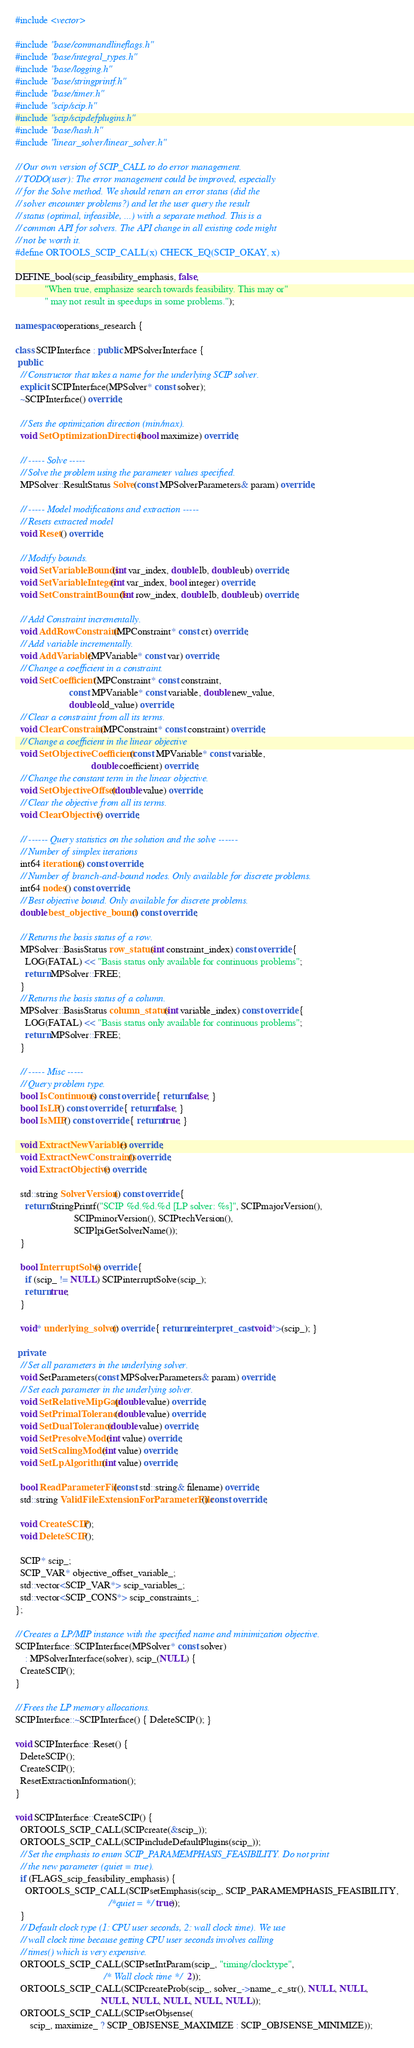Convert code to text. <code><loc_0><loc_0><loc_500><loc_500><_C++_>#include <vector>

#include "base/commandlineflags.h"
#include "base/integral_types.h"
#include "base/logging.h"
#include "base/stringprintf.h"
#include "base/timer.h"
#include "scip/scip.h"
#include "scip/scipdefplugins.h"
#include "base/hash.h"
#include "linear_solver/linear_solver.h"

// Our own version of SCIP_CALL to do error management.
// TODO(user): The error management could be improved, especially
// for the Solve method. We should return an error status (did the
// solver encounter problems?) and let the user query the result
// status (optimal, infeasible, ...) with a separate method. This is a
// common API for solvers. The API change in all existing code might
// not be worth it.
#define ORTOOLS_SCIP_CALL(x) CHECK_EQ(SCIP_OKAY, x)

DEFINE_bool(scip_feasibility_emphasis, false,
            "When true, emphasize search towards feasibility. This may or"
            " may not result in speedups in some problems.");

namespace operations_research {

class SCIPInterface : public MPSolverInterface {
 public:
  // Constructor that takes a name for the underlying SCIP solver.
  explicit SCIPInterface(MPSolver* const solver);
  ~SCIPInterface() override;

  // Sets the optimization direction (min/max).
  void SetOptimizationDirection(bool maximize) override;

  // ----- Solve -----
  // Solve the problem using the parameter values specified.
  MPSolver::ResultStatus Solve(const MPSolverParameters& param) override;

  // ----- Model modifications and extraction -----
  // Resets extracted model
  void Reset() override;

  // Modify bounds.
  void SetVariableBounds(int var_index, double lb, double ub) override;
  void SetVariableInteger(int var_index, bool integer) override;
  void SetConstraintBounds(int row_index, double lb, double ub) override;

  // Add Constraint incrementally.
  void AddRowConstraint(MPConstraint* const ct) override;
  // Add variable incrementally.
  void AddVariable(MPVariable* const var) override;
  // Change a coefficient in a constraint.
  void SetCoefficient(MPConstraint* const constraint,
                      const MPVariable* const variable, double new_value,
                      double old_value) override;
  // Clear a constraint from all its terms.
  void ClearConstraint(MPConstraint* const constraint) override;
  // Change a coefficient in the linear objective
  void SetObjectiveCoefficient(const MPVariable* const variable,
                               double coefficient) override;
  // Change the constant term in the linear objective.
  void SetObjectiveOffset(double value) override;
  // Clear the objective from all its terms.
  void ClearObjective() override;

  // ------ Query statistics on the solution and the solve ------
  // Number of simplex iterations
  int64 iterations() const override;
  // Number of branch-and-bound nodes. Only available for discrete problems.
  int64 nodes() const override;
  // Best objective bound. Only available for discrete problems.
  double best_objective_bound() const override;

  // Returns the basis status of a row.
  MPSolver::BasisStatus row_status(int constraint_index) const override {
    LOG(FATAL) << "Basis status only available for continuous problems";
    return MPSolver::FREE;
  }
  // Returns the basis status of a column.
  MPSolver::BasisStatus column_status(int variable_index) const override {
    LOG(FATAL) << "Basis status only available for continuous problems";
    return MPSolver::FREE;
  }

  // ----- Misc -----
  // Query problem type.
  bool IsContinuous() const override { return false; }
  bool IsLP() const override { return false; }
  bool IsMIP() const override { return true; }

  void ExtractNewVariables() override;
  void ExtractNewConstraints() override;
  void ExtractObjective() override;

  std::string SolverVersion() const override {
    return StringPrintf("SCIP %d.%d.%d [LP solver: %s]", SCIPmajorVersion(),
                        SCIPminorVersion(), SCIPtechVersion(),
                        SCIPlpiGetSolverName());
  }

  bool InterruptSolve() override {
    if (scip_ != NULL) SCIPinterruptSolve(scip_);
    return true;
  }

  void* underlying_solver() override { return reinterpret_cast<void*>(scip_); }

 private:
  // Set all parameters in the underlying solver.
  void SetParameters(const MPSolverParameters& param) override;
  // Set each parameter in the underlying solver.
  void SetRelativeMipGap(double value) override;
  void SetPrimalTolerance(double value) override;
  void SetDualTolerance(double value) override;
  void SetPresolveMode(int value) override;
  void SetScalingMode(int value) override;
  void SetLpAlgorithm(int value) override;

  bool ReadParameterFile(const std::string& filename) override;
  std::string ValidFileExtensionForParameterFile() const override;

  void CreateSCIP();
  void DeleteSCIP();

  SCIP* scip_;
  SCIP_VAR* objective_offset_variable_;
  std::vector<SCIP_VAR*> scip_variables_;
  std::vector<SCIP_CONS*> scip_constraints_;
};

// Creates a LP/MIP instance with the specified name and minimization objective.
SCIPInterface::SCIPInterface(MPSolver* const solver)
    : MPSolverInterface(solver), scip_(NULL) {
  CreateSCIP();
}

// Frees the LP memory allocations.
SCIPInterface::~SCIPInterface() { DeleteSCIP(); }

void SCIPInterface::Reset() {
  DeleteSCIP();
  CreateSCIP();
  ResetExtractionInformation();
}

void SCIPInterface::CreateSCIP() {
  ORTOOLS_SCIP_CALL(SCIPcreate(&scip_));
  ORTOOLS_SCIP_CALL(SCIPincludeDefaultPlugins(scip_));
  // Set the emphasis to enum SCIP_PARAMEMPHASIS_FEASIBILITY. Do not print
  // the new parameter (quiet = true).
  if (FLAGS_scip_feasibility_emphasis) {
    ORTOOLS_SCIP_CALL(SCIPsetEmphasis(scip_, SCIP_PARAMEMPHASIS_FEASIBILITY,
                                      /*quiet = */ true));
  }
  // Default clock type (1: CPU user seconds, 2: wall clock time). We use
  // wall clock time because getting CPU user seconds involves calling
  // times() which is very expensive.
  ORTOOLS_SCIP_CALL(SCIPsetIntParam(scip_, "timing/clocktype",
                                    /* Wall clock time */ 2));
  ORTOOLS_SCIP_CALL(SCIPcreateProb(scip_, solver_->name_.c_str(), NULL, NULL,
                                   NULL, NULL, NULL, NULL, NULL));
  ORTOOLS_SCIP_CALL(SCIPsetObjsense(
      scip_, maximize_ ? SCIP_OBJSENSE_MAXIMIZE : SCIP_OBJSENSE_MINIMIZE));</code> 